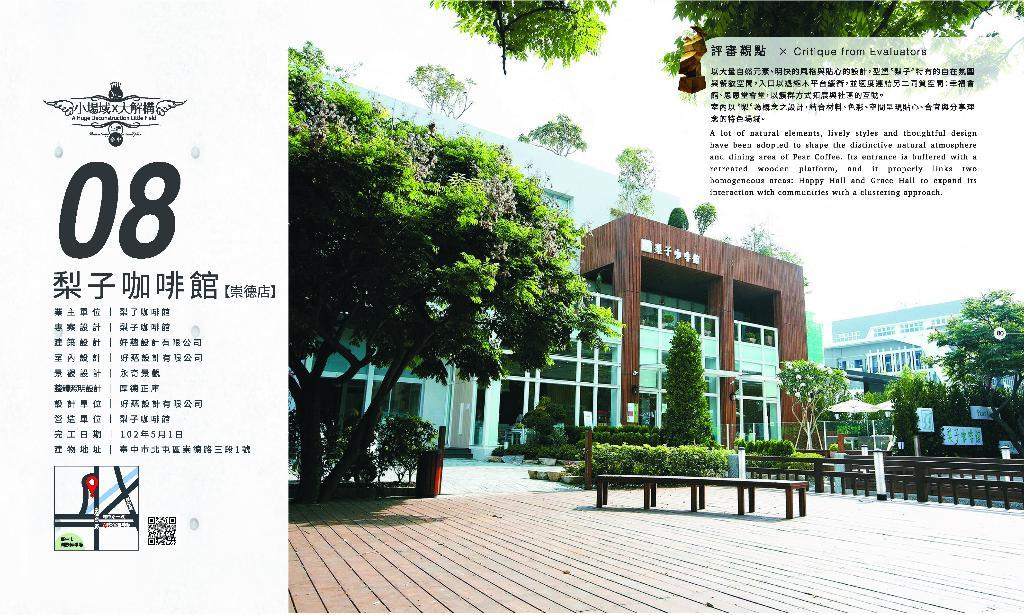What type of structures can be seen in the image? There are buildings in the image. What natural elements are present in the image? There are trees in the image. What type of seating is available in front of the buildings? There are benches in front of the buildings. Is there any text or writing visible in the image? Yes, some text is written on the image. Can you see any tongues sticking out from behind the buildings in the image? No, there are no tongues visible in the image. 